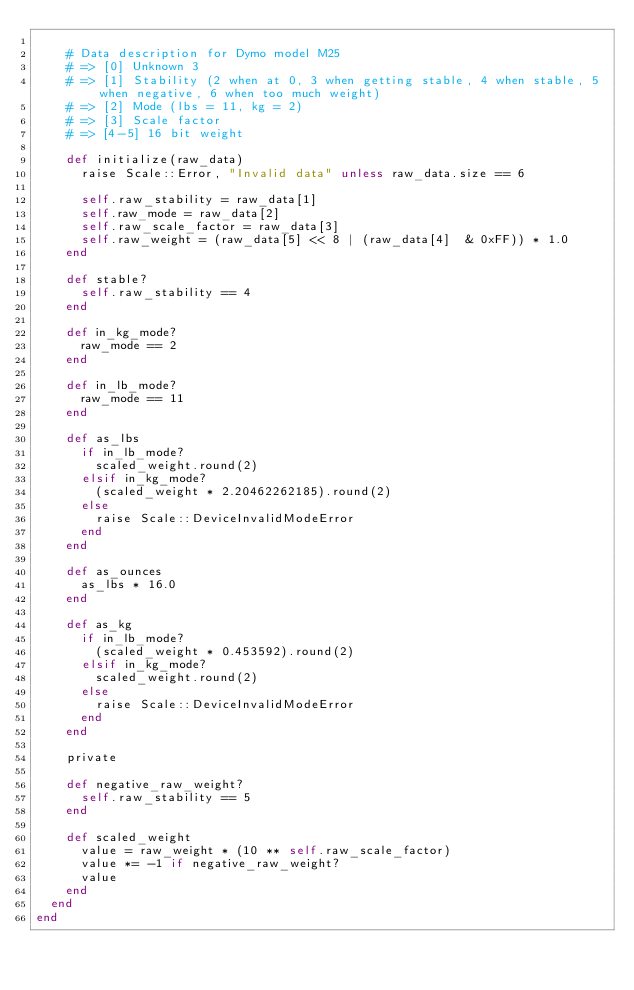<code> <loc_0><loc_0><loc_500><loc_500><_Ruby_>
    # Data description for Dymo model M25
    # => [0] Unknown 3
    # => [1] Stability (2 when at 0, 3 when getting stable, 4 when stable, 5 when negative, 6 when too much weight)
    # => [2] Mode (lbs = 11, kg = 2)
    # => [3] Scale factor
    # => [4-5] 16 bit weight

    def initialize(raw_data)
      raise Scale::Error, "Invalid data" unless raw_data.size == 6

      self.raw_stability = raw_data[1]
      self.raw_mode = raw_data[2]
      self.raw_scale_factor = raw_data[3]
      self.raw_weight = (raw_data[5] << 8 | (raw_data[4]  & 0xFF)) * 1.0
    end

    def stable?
      self.raw_stability == 4
    end

    def in_kg_mode?
      raw_mode == 2
    end

    def in_lb_mode?
      raw_mode == 11
    end

    def as_lbs
      if in_lb_mode?
        scaled_weight.round(2)
      elsif in_kg_mode?
        (scaled_weight * 2.20462262185).round(2)
      else
        raise Scale::DeviceInvalidModeError
      end
    end

    def as_ounces
      as_lbs * 16.0
    end

    def as_kg
      if in_lb_mode?
        (scaled_weight * 0.453592).round(2)
      elsif in_kg_mode?
        scaled_weight.round(2)
      else
        raise Scale::DeviceInvalidModeError
      end
    end

    private

    def negative_raw_weight?
      self.raw_stability == 5
    end

    def scaled_weight
      value = raw_weight * (10 ** self.raw_scale_factor)
      value *= -1 if negative_raw_weight?
      value
    end
  end
end
</code> 